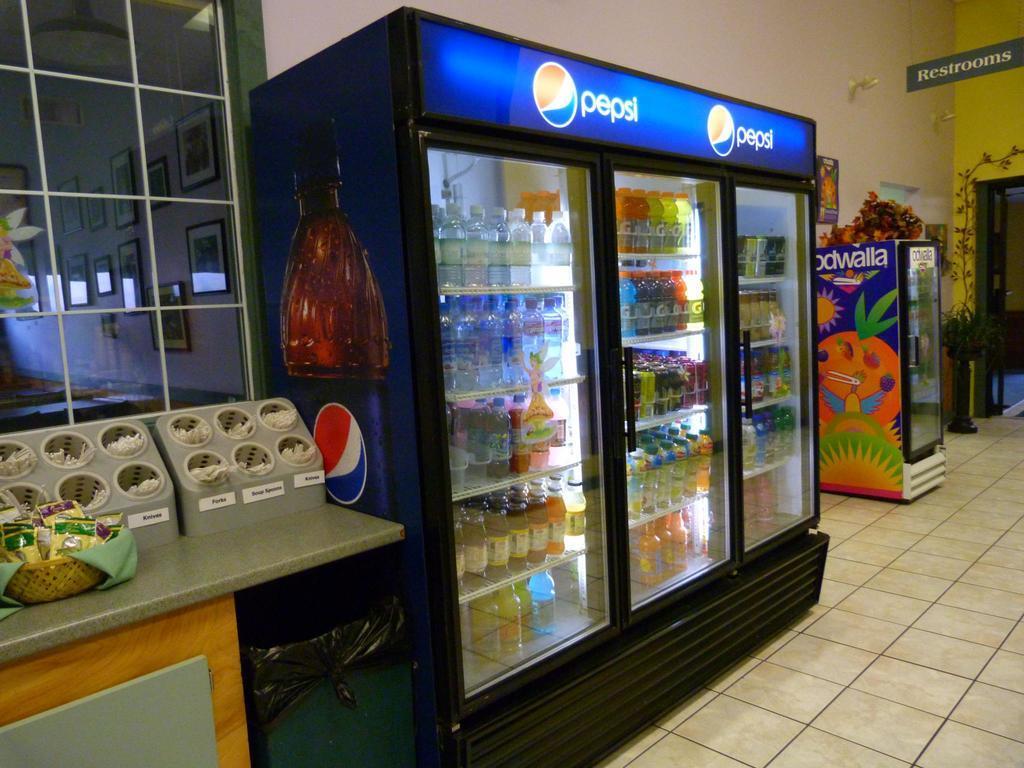Please provide a concise description of this image. In this image we can see there is a big fridge with so many bottles, behind that there is a table with some food stuff and also there is a restroom board on the top. 